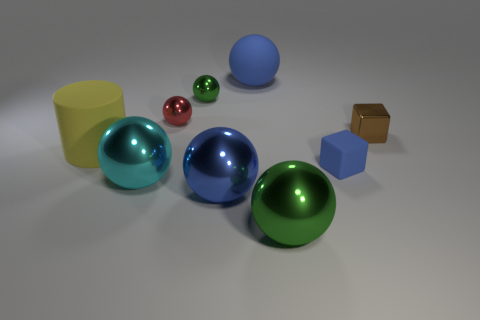Subtract all blue metallic balls. How many balls are left? 5 Subtract all red cylinders. How many blue balls are left? 2 Subtract 2 spheres. How many spheres are left? 4 Subtract all red spheres. How many spheres are left? 5 Subtract all cylinders. How many objects are left? 8 Subtract all small blue matte things. Subtract all tiny brown metallic blocks. How many objects are left? 7 Add 5 large rubber balls. How many large rubber balls are left? 6 Add 2 metal cubes. How many metal cubes exist? 3 Subtract 0 cyan cylinders. How many objects are left? 9 Subtract all brown spheres. Subtract all brown blocks. How many spheres are left? 6 